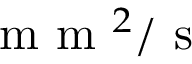<formula> <loc_0><loc_0><loc_500><loc_500>m m ^ { 2 } / s</formula> 